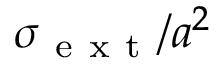<formula> <loc_0><loc_0><loc_500><loc_500>\sigma _ { e x t } / a ^ { 2 }</formula> 